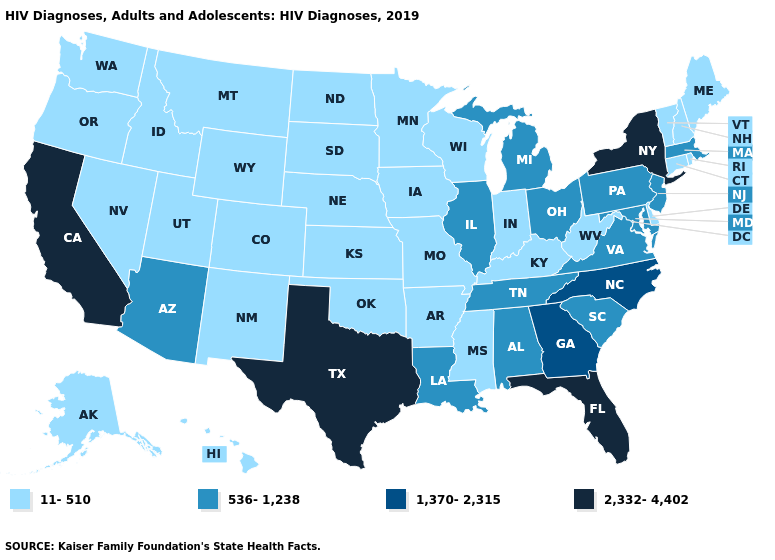Name the states that have a value in the range 2,332-4,402?
Give a very brief answer. California, Florida, New York, Texas. What is the lowest value in the Northeast?
Short answer required. 11-510. Does Hawaii have a lower value than Georgia?
Write a very short answer. Yes. Name the states that have a value in the range 11-510?
Be succinct. Alaska, Arkansas, Colorado, Connecticut, Delaware, Hawaii, Idaho, Indiana, Iowa, Kansas, Kentucky, Maine, Minnesota, Mississippi, Missouri, Montana, Nebraska, Nevada, New Hampshire, New Mexico, North Dakota, Oklahoma, Oregon, Rhode Island, South Dakota, Utah, Vermont, Washington, West Virginia, Wisconsin, Wyoming. Does Idaho have the lowest value in the USA?
Give a very brief answer. Yes. Does the first symbol in the legend represent the smallest category?
Give a very brief answer. Yes. Does New Jersey have the same value as California?
Concise answer only. No. Name the states that have a value in the range 2,332-4,402?
Concise answer only. California, Florida, New York, Texas. Which states have the highest value in the USA?
Write a very short answer. California, Florida, New York, Texas. Does New Hampshire have the same value as Kansas?
Short answer required. Yes. What is the value of Indiana?
Keep it brief. 11-510. Name the states that have a value in the range 536-1,238?
Short answer required. Alabama, Arizona, Illinois, Louisiana, Maryland, Massachusetts, Michigan, New Jersey, Ohio, Pennsylvania, South Carolina, Tennessee, Virginia. Does Delaware have the lowest value in the USA?
Quick response, please. Yes. What is the value of South Dakota?
Be succinct. 11-510. Name the states that have a value in the range 2,332-4,402?
Write a very short answer. California, Florida, New York, Texas. 